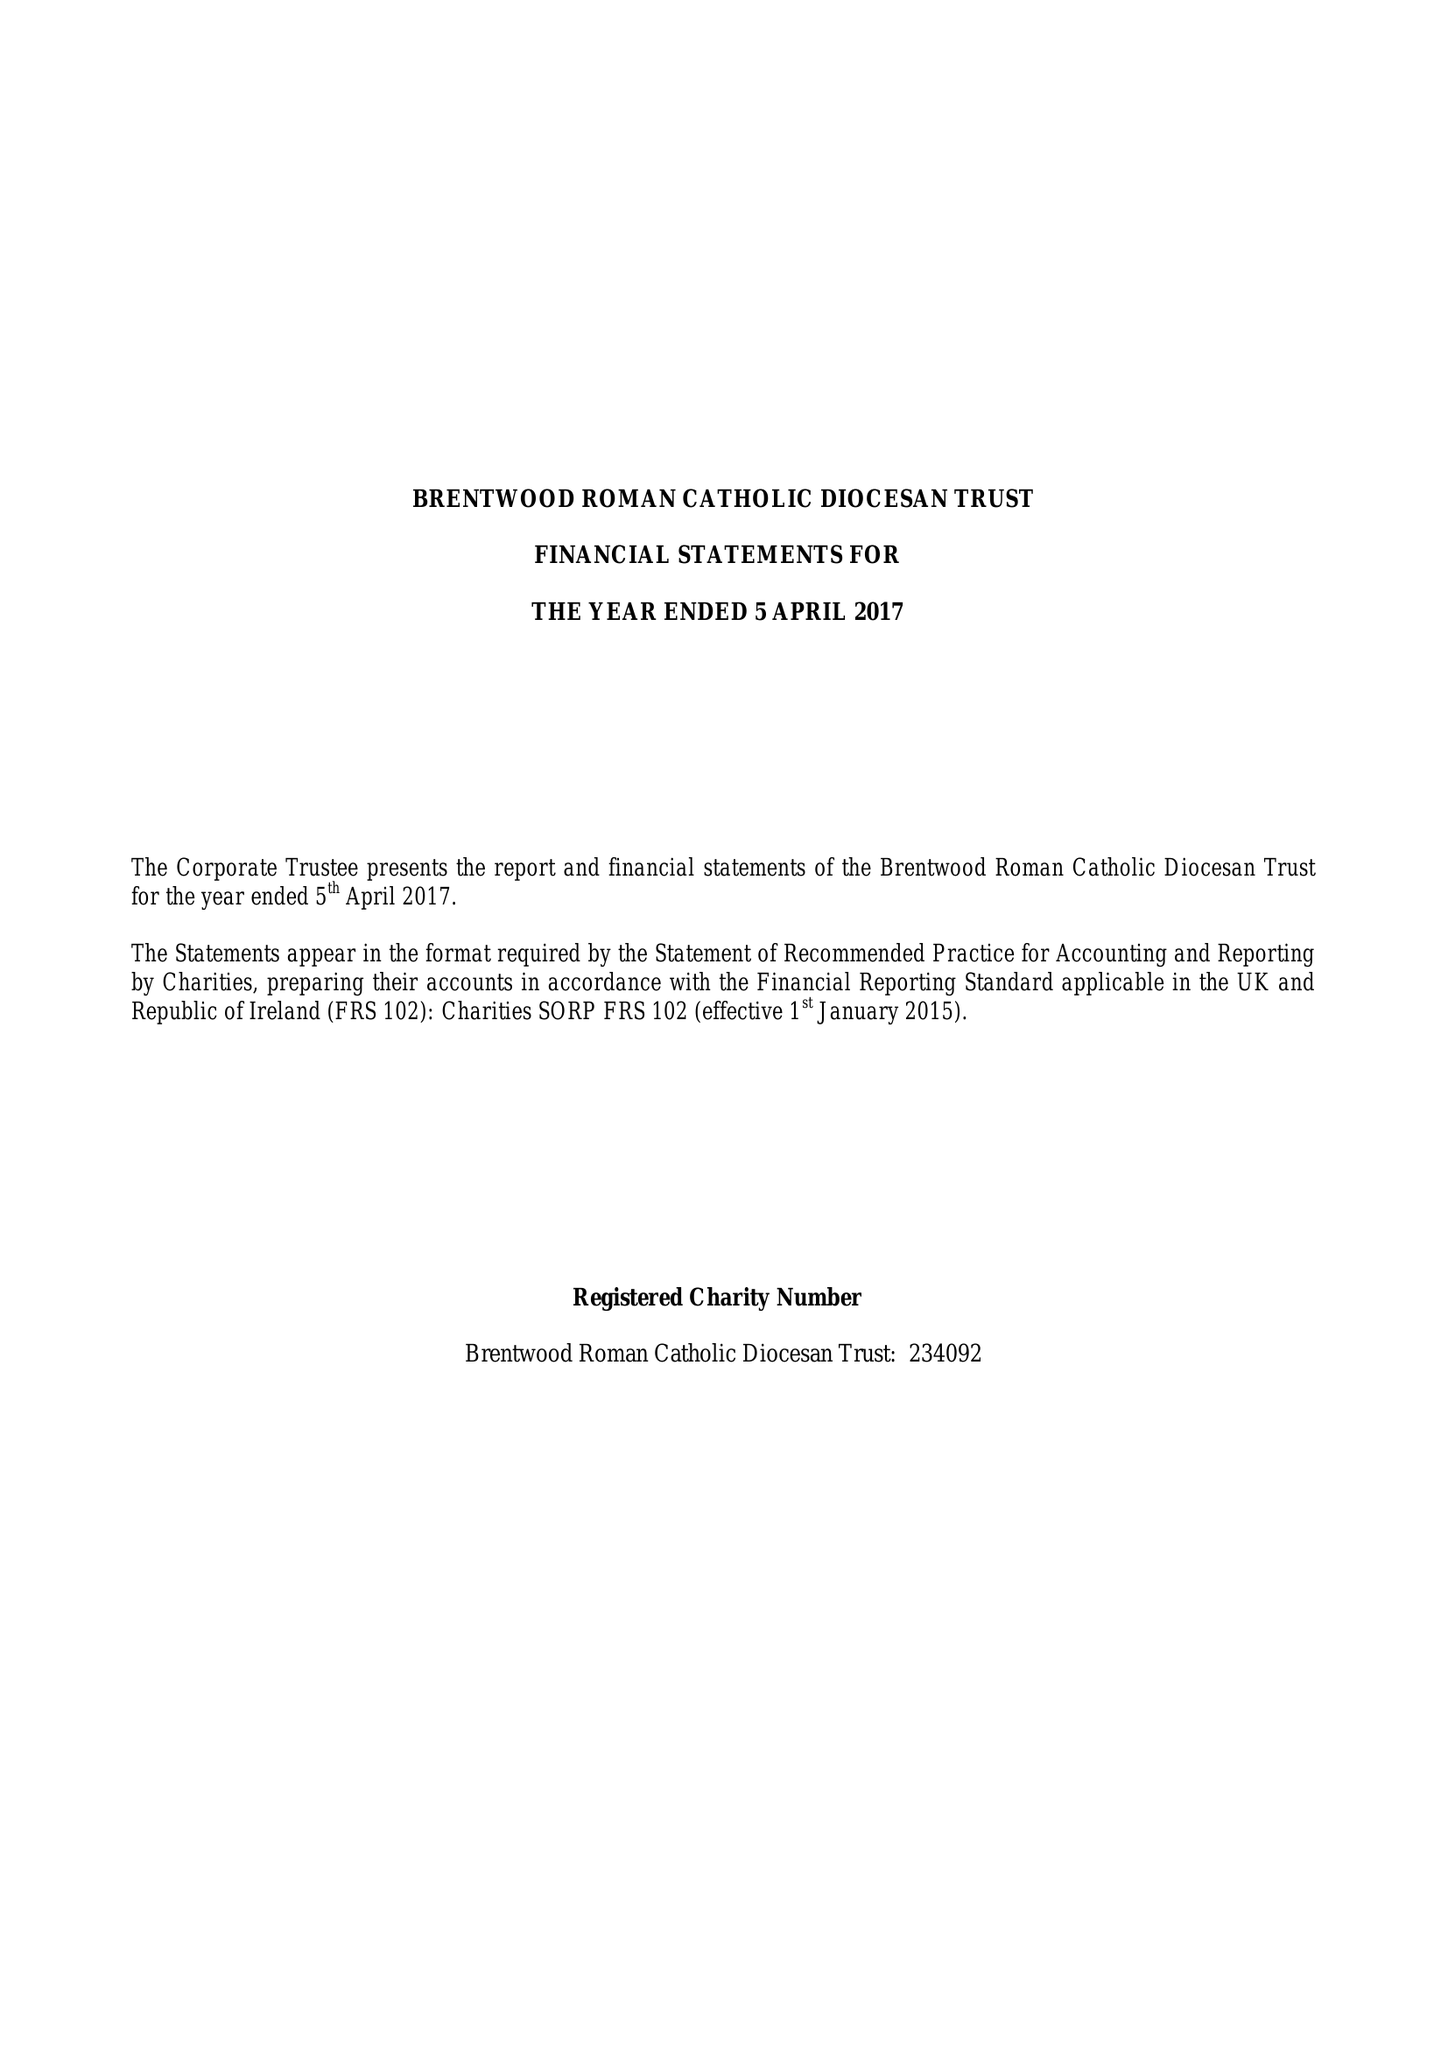What is the value for the spending_annually_in_british_pounds?
Answer the question using a single word or phrase. 11715255.00 